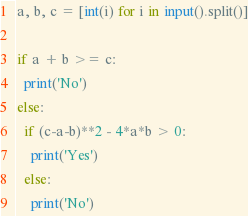Convert code to text. <code><loc_0><loc_0><loc_500><loc_500><_Python_>a, b, c = [int(i) for i in input().split()]

if a + b >= c:
  print('No')
else:
  if (c-a-b)**2 - 4*a*b > 0:
    print('Yes')
  else:
    print('No')</code> 